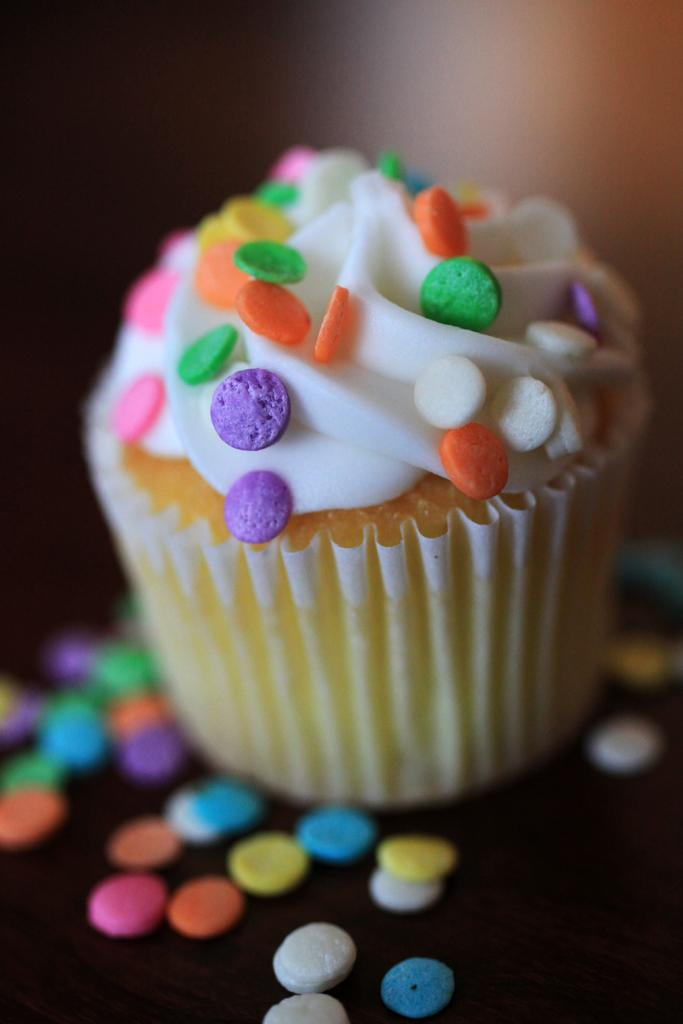What type of food item is present in the image? There is a cupcake in the image. What is placed on top of the cupcake? There are candles in the image. What are the candles resting on? The candles are on an object. Can you describe the background of the image? The background of the image is blurry. What type of business is being conducted in the image? There is no indication of a business being conducted in the image; it primarily features a cupcake with candles. What role does chalk play in the image? There is no chalk present in the image. 